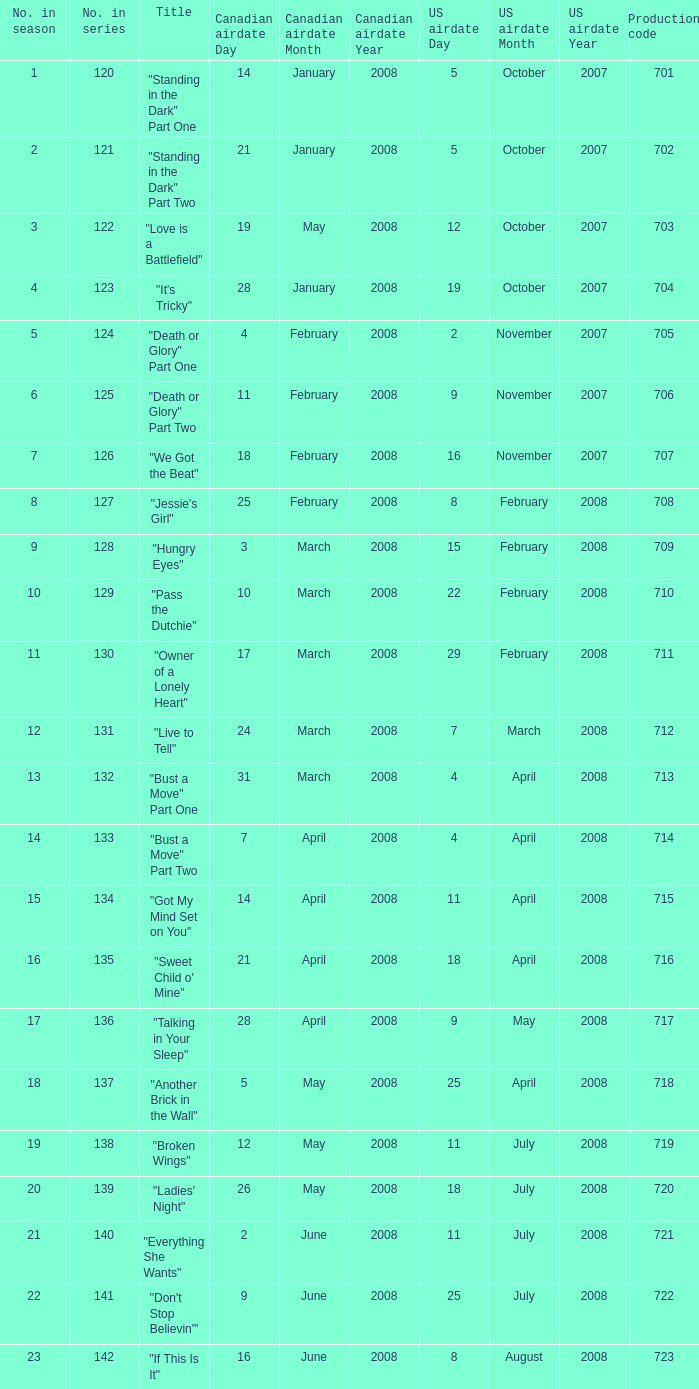The U.S. airdate of 4 april 2008 had a production code of what? 714.0. 